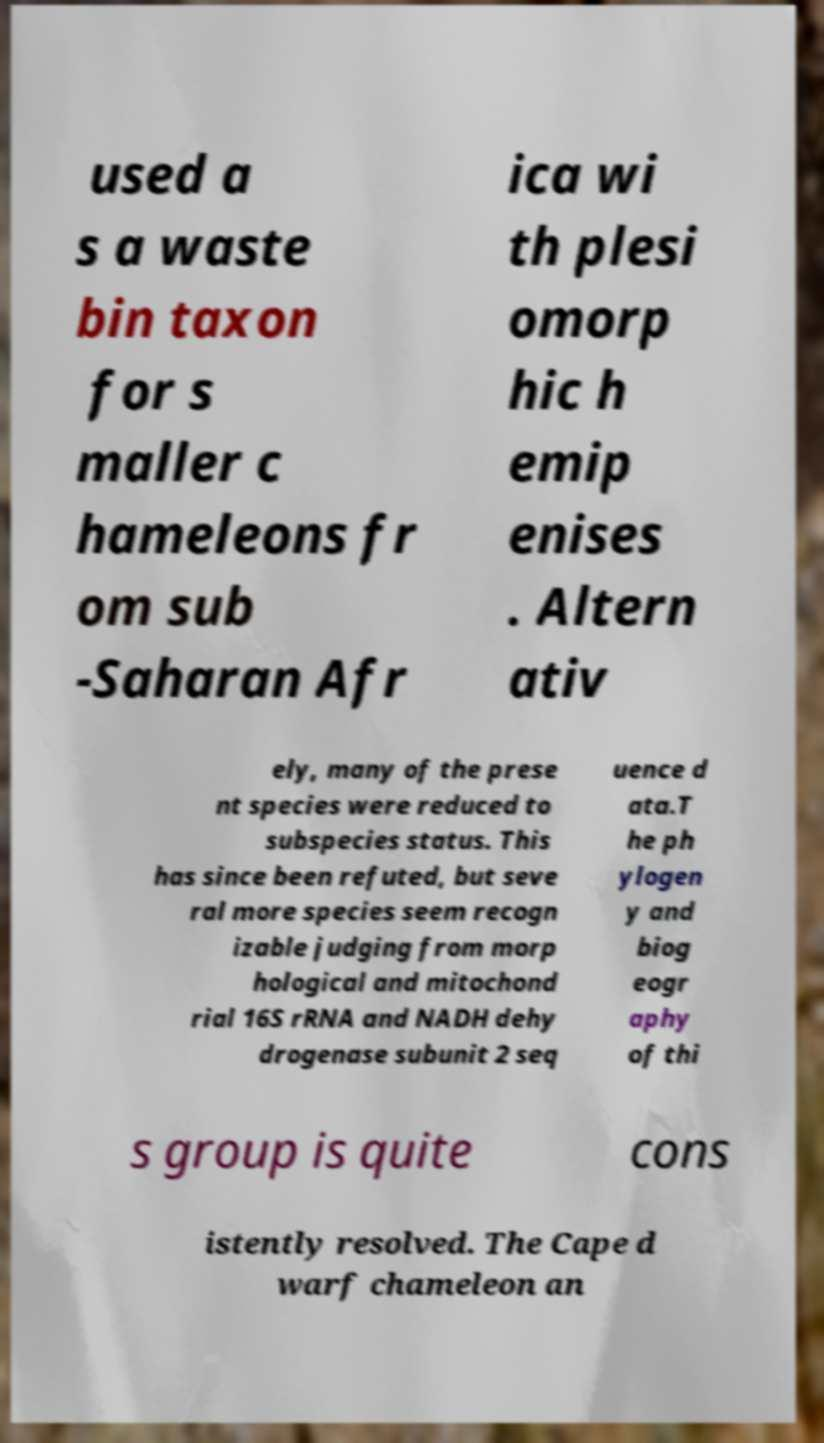What messages or text are displayed in this image? I need them in a readable, typed format. used a s a waste bin taxon for s maller c hameleons fr om sub -Saharan Afr ica wi th plesi omorp hic h emip enises . Altern ativ ely, many of the prese nt species were reduced to subspecies status. This has since been refuted, but seve ral more species seem recogn izable judging from morp hological and mitochond rial 16S rRNA and NADH dehy drogenase subunit 2 seq uence d ata.T he ph ylogen y and biog eogr aphy of thi s group is quite cons istently resolved. The Cape d warf chameleon an 